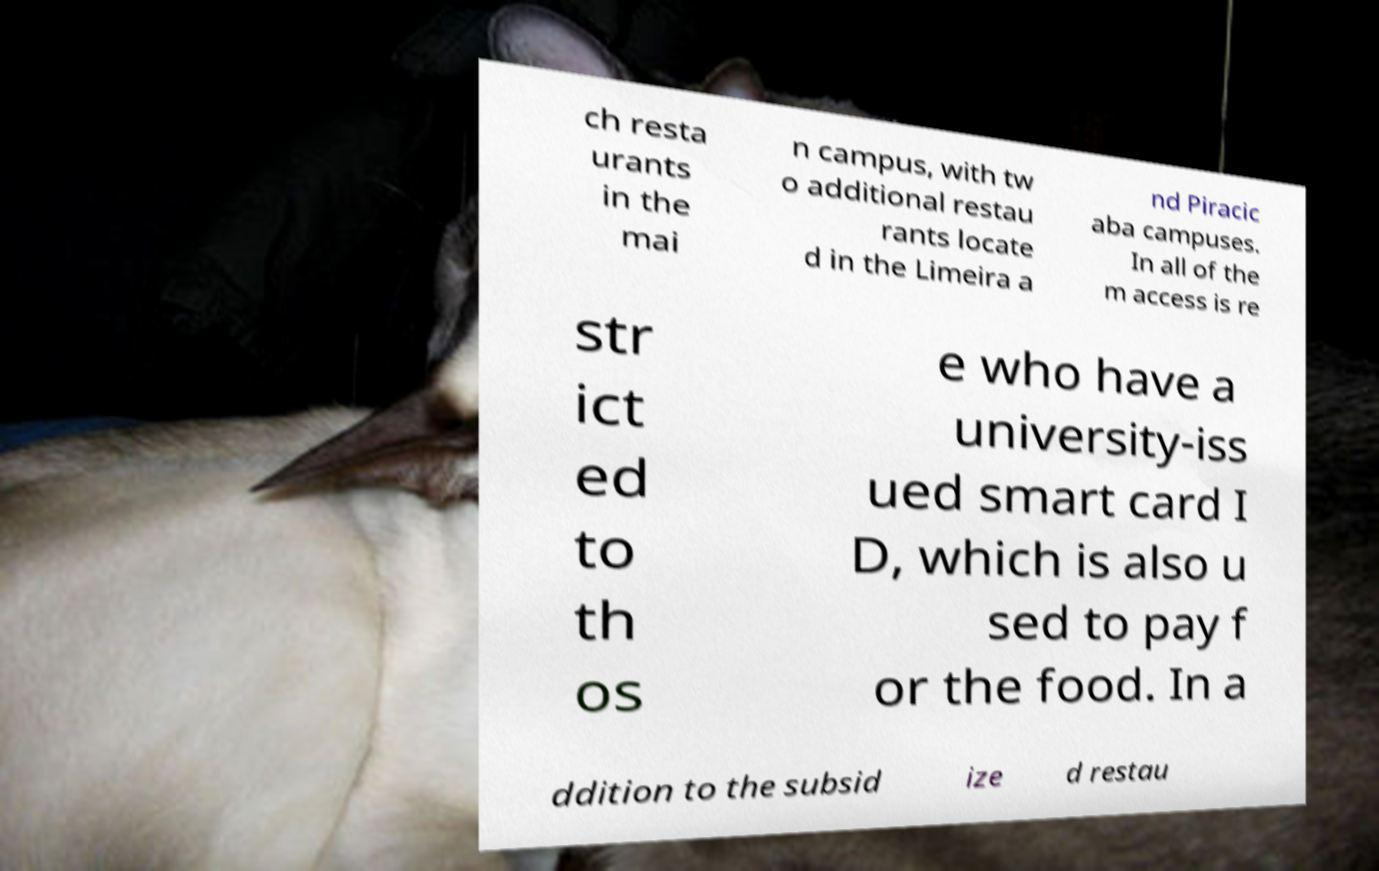I need the written content from this picture converted into text. Can you do that? ch resta urants in the mai n campus, with tw o additional restau rants locate d in the Limeira a nd Piracic aba campuses. In all of the m access is re str ict ed to th os e who have a university-iss ued smart card I D, which is also u sed to pay f or the food. In a ddition to the subsid ize d restau 